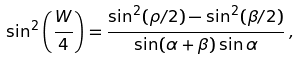<formula> <loc_0><loc_0><loc_500><loc_500>\sin ^ { 2 } \left ( \frac { W } { 4 } \right ) = \frac { \sin ^ { 2 } ( \rho / 2 ) - \sin ^ { 2 } ( \beta / 2 ) } { \sin ( \alpha + \beta ) \sin \alpha } \, ,</formula> 